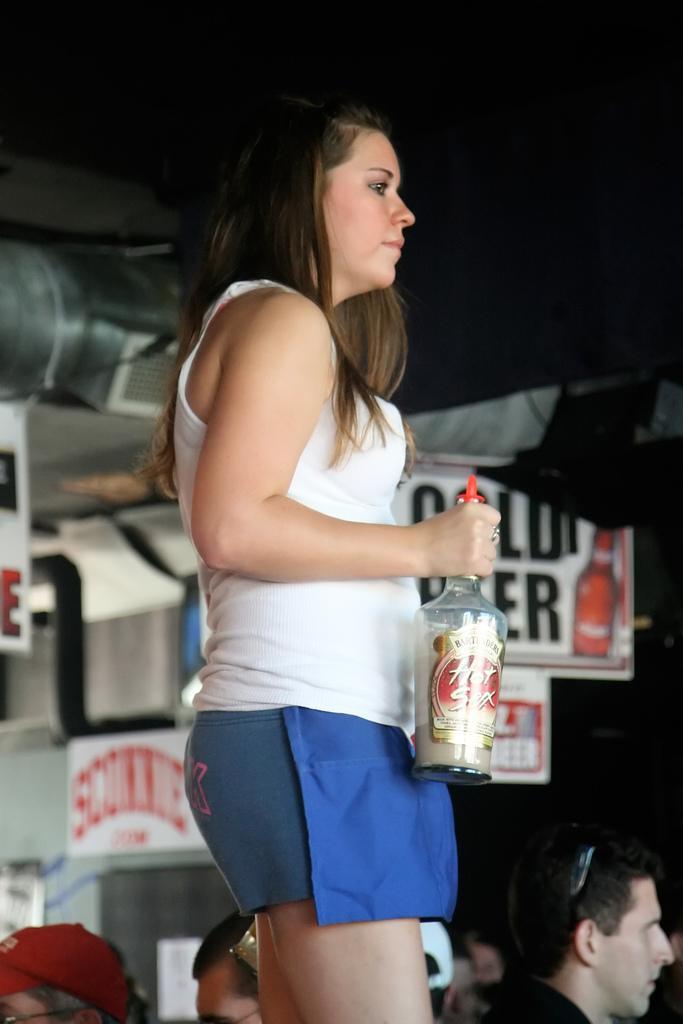Could you give a brief overview of what you see in this image? In this picture a lady holding a glass bottle in one of her hands. In the background there is a label called BEER with red bottle symbol beside it. There are also AC extinguishers to the top of the roof. 